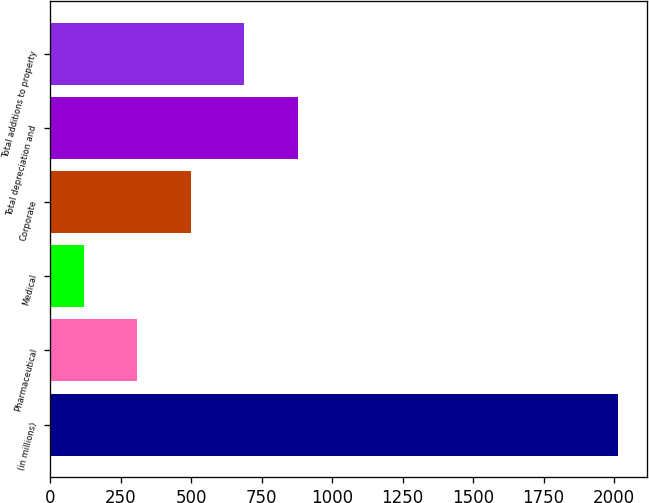Convert chart. <chart><loc_0><loc_0><loc_500><loc_500><bar_chart><fcel>(in millions)<fcel>Pharmaceutical<fcel>Medical<fcel>Corporate<fcel>Total depreciation and<fcel>Total additions to property<nl><fcel>2015<fcel>308.6<fcel>119<fcel>498.2<fcel>877.4<fcel>687.8<nl></chart> 